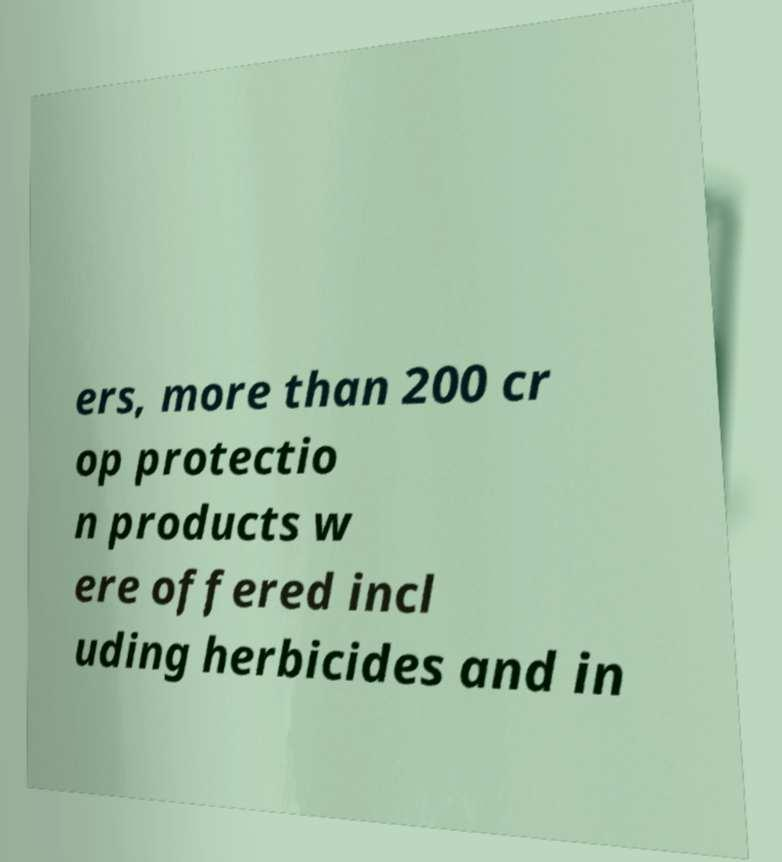For documentation purposes, I need the text within this image transcribed. Could you provide that? ers, more than 200 cr op protectio n products w ere offered incl uding herbicides and in 